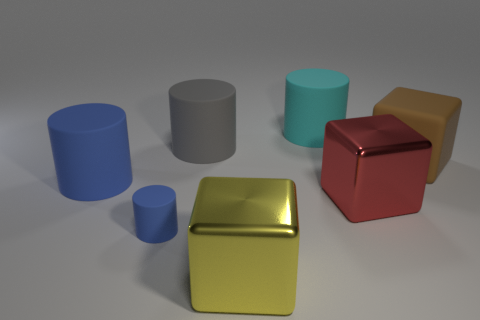Does the large cyan thing have the same material as the gray cylinder that is behind the small blue rubber cylinder?
Make the answer very short. Yes. The brown cube that is the same material as the large gray cylinder is what size?
Give a very brief answer. Large. Is there another gray metal thing that has the same shape as the gray object?
Give a very brief answer. No. What number of things are gray cylinders in front of the cyan thing or large gray rubber objects?
Your answer should be very brief. 1. The cylinder that is the same color as the tiny rubber thing is what size?
Ensure brevity in your answer.  Large. Is the color of the big cylinder on the right side of the big yellow metal object the same as the large thing on the left side of the gray matte thing?
Your response must be concise. No. How big is the gray thing?
Provide a short and direct response. Large. What number of large objects are green spheres or cylinders?
Your answer should be compact. 3. What color is the matte cube that is the same size as the cyan cylinder?
Ensure brevity in your answer.  Brown. What number of other objects are there of the same shape as the tiny blue matte object?
Offer a very short reply. 3. 